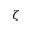<formula> <loc_0><loc_0><loc_500><loc_500>\zeta</formula> 